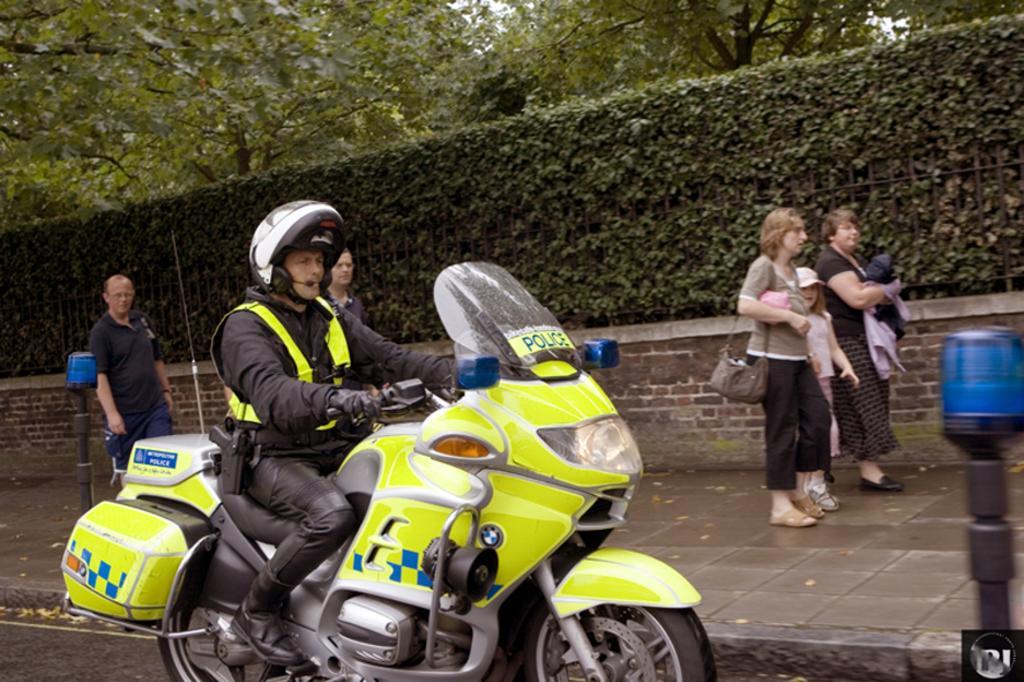In one or two sentences, can you explain what this image depicts? In this picture we can see a man sitting on bike wore helmet, jacket and riding the bike and beside to him there is a foot path and some persons are walking on foot path and in background we can see trees. 